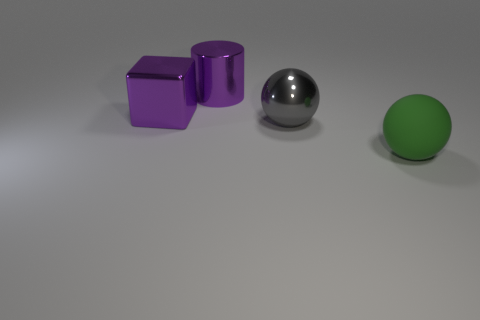There is a big cylinder that is the same color as the big shiny cube; what is it made of?
Keep it short and to the point. Metal. The thing that is the same color as the cylinder is what size?
Provide a succinct answer. Large. What size is the thing that is on the right side of the big cylinder and behind the matte object?
Your answer should be very brief. Large. The big thing that is right of the purple block and behind the gray metal thing is what color?
Provide a succinct answer. Purple. Is there any other thing that has the same material as the big gray sphere?
Provide a short and direct response. Yes. Is the number of gray metallic spheres that are in front of the big rubber thing less than the number of objects that are on the left side of the purple cylinder?
Your response must be concise. Yes. Is there any other thing that is the same color as the shiny ball?
Offer a very short reply. No. What color is the big cylinder that is made of the same material as the gray thing?
Offer a very short reply. Purple. Are there more metal balls than small red metal objects?
Provide a succinct answer. Yes. Are there any brown matte spheres?
Provide a succinct answer. No. 